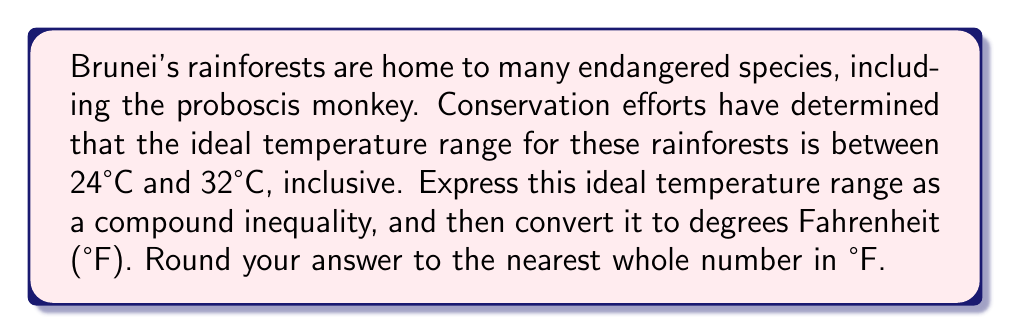Solve this math problem. 1. Express the ideal temperature range as a compound inequality in °C:
   $$24 \leq T \leq 32$$
   where $T$ represents the temperature in °C.

2. To convert this range to °F, we'll use the formula:
   $$°F = \frac{9}{5}°C + 32$$

3. Convert the lower bound (24°C):
   $$\frac{9}{5}(24) + 32 = 43.2 + 32 = 75.2°F$$

4. Convert the upper bound (32°C):
   $$\frac{9}{5}(32) + 32 = 57.6 + 32 = 89.6°F$$

5. Round to the nearest whole number:
   75.2°F ≈ 75°F
   89.6°F ≈ 90°F

6. Express the final compound inequality in °F:
   $$75 \leq T \leq 90$$
   where $T$ now represents the temperature in °F.
Answer: $75 \leq T \leq 90$ (in °F) 